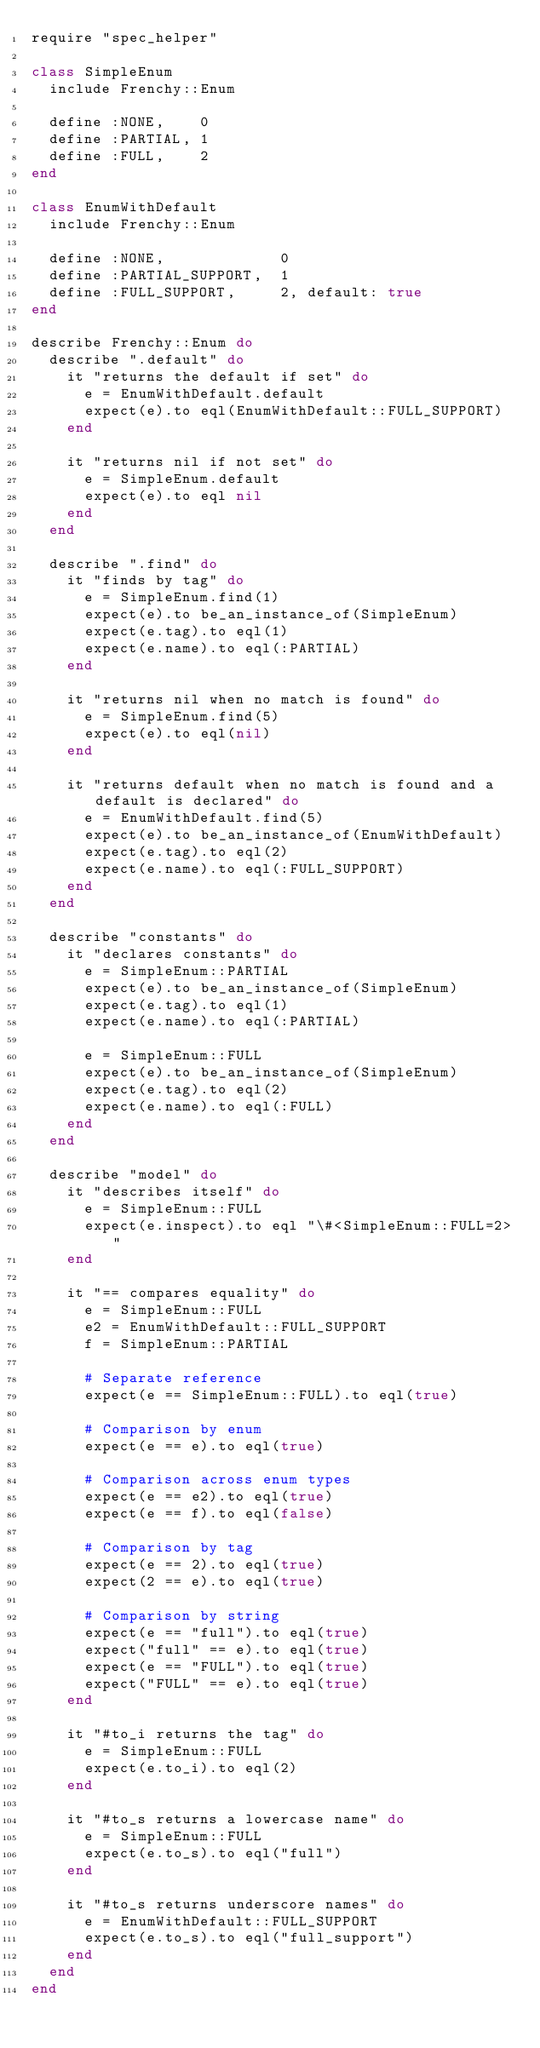<code> <loc_0><loc_0><loc_500><loc_500><_Ruby_>require "spec_helper"

class SimpleEnum
  include Frenchy::Enum

  define :NONE,    0
  define :PARTIAL, 1
  define :FULL,    2
end

class EnumWithDefault
  include Frenchy::Enum

  define :NONE,             0
  define :PARTIAL_SUPPORT,  1
  define :FULL_SUPPORT,     2, default: true
end

describe Frenchy::Enum do
  describe ".default" do
    it "returns the default if set" do
      e = EnumWithDefault.default
      expect(e).to eql(EnumWithDefault::FULL_SUPPORT)
    end

    it "returns nil if not set" do
      e = SimpleEnum.default
      expect(e).to eql nil
    end
  end

  describe ".find" do
    it "finds by tag" do
      e = SimpleEnum.find(1)
      expect(e).to be_an_instance_of(SimpleEnum)
      expect(e.tag).to eql(1)
      expect(e.name).to eql(:PARTIAL)
    end

    it "returns nil when no match is found" do
      e = SimpleEnum.find(5)
      expect(e).to eql(nil)
    end

    it "returns default when no match is found and a default is declared" do
      e = EnumWithDefault.find(5)
      expect(e).to be_an_instance_of(EnumWithDefault)
      expect(e.tag).to eql(2)
      expect(e.name).to eql(:FULL_SUPPORT)
    end
  end

  describe "constants" do
    it "declares constants" do
      e = SimpleEnum::PARTIAL
      expect(e).to be_an_instance_of(SimpleEnum)
      expect(e.tag).to eql(1)
      expect(e.name).to eql(:PARTIAL)

      e = SimpleEnum::FULL
      expect(e).to be_an_instance_of(SimpleEnum)
      expect(e.tag).to eql(2)
      expect(e.name).to eql(:FULL)
    end
  end

  describe "model" do
    it "describes itself" do
      e = SimpleEnum::FULL
      expect(e.inspect).to eql "\#<SimpleEnum::FULL=2>"
    end

    it "== compares equality" do
      e = SimpleEnum::FULL
      e2 = EnumWithDefault::FULL_SUPPORT
      f = SimpleEnum::PARTIAL

      # Separate reference
      expect(e == SimpleEnum::FULL).to eql(true)

      # Comparison by enum
      expect(e == e).to eql(true)

      # Comparison across enum types
      expect(e == e2).to eql(true)
      expect(e == f).to eql(false)

      # Comparison by tag
      expect(e == 2).to eql(true)
      expect(2 == e).to eql(true)

      # Comparison by string
      expect(e == "full").to eql(true)
      expect("full" == e).to eql(true)
      expect(e == "FULL").to eql(true)
      expect("FULL" == e).to eql(true)
    end

    it "#to_i returns the tag" do
      e = SimpleEnum::FULL
      expect(e.to_i).to eql(2)
    end

    it "#to_s returns a lowercase name" do
      e = SimpleEnum::FULL
      expect(e.to_s).to eql("full")
    end

    it "#to_s returns underscore names" do
      e = EnumWithDefault::FULL_SUPPORT
      expect(e.to_s).to eql("full_support")
    end
  end
end</code> 